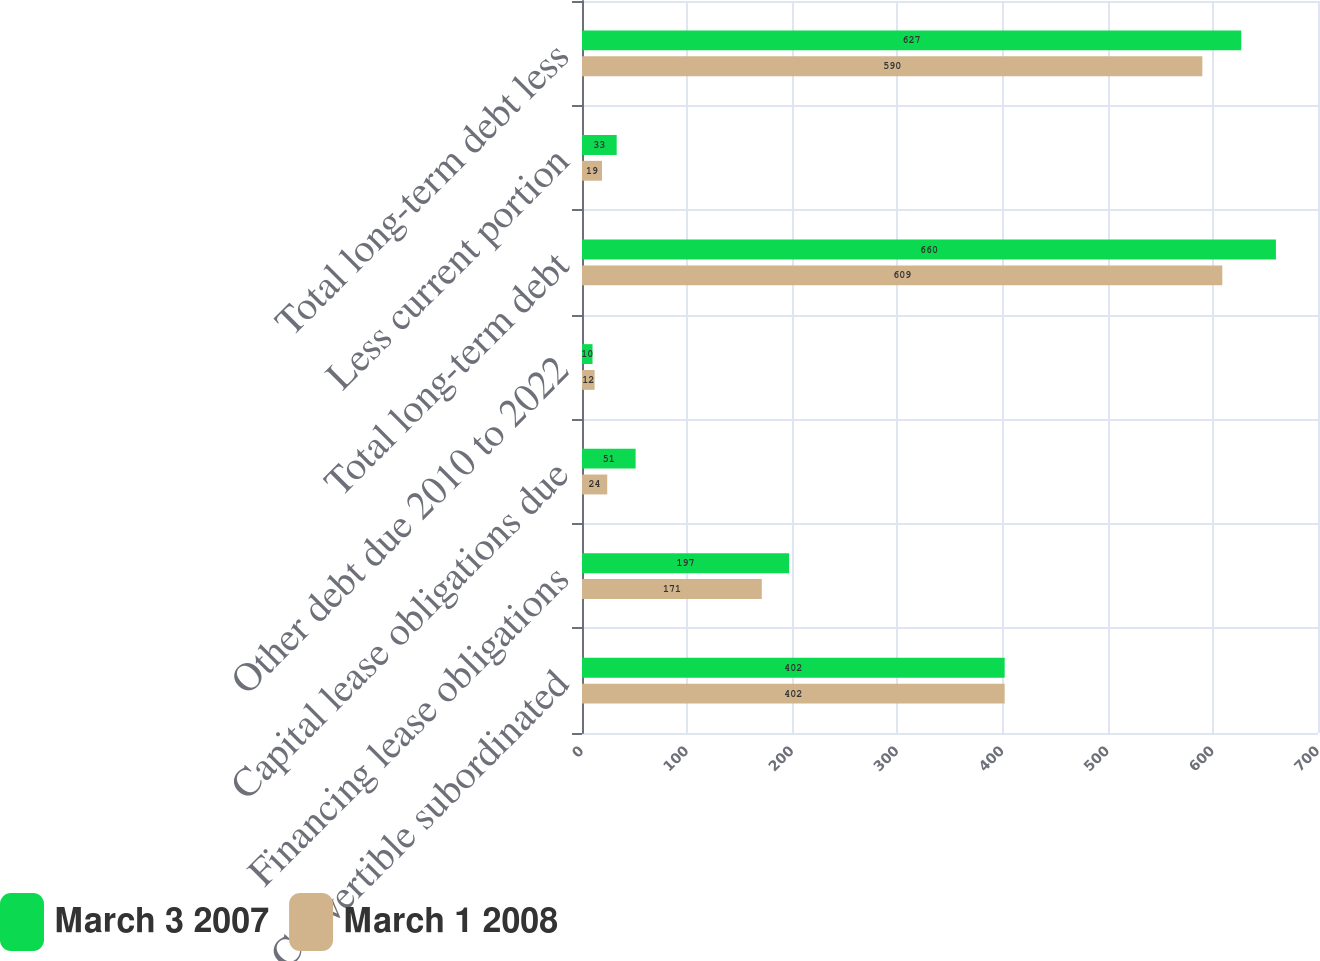Convert chart. <chart><loc_0><loc_0><loc_500><loc_500><stacked_bar_chart><ecel><fcel>Convertible subordinated<fcel>Financing lease obligations<fcel>Capital lease obligations due<fcel>Other debt due 2010 to 2022<fcel>Total long-term debt<fcel>Less current portion<fcel>Total long-term debt less<nl><fcel>March 3 2007<fcel>402<fcel>197<fcel>51<fcel>10<fcel>660<fcel>33<fcel>627<nl><fcel>March 1 2008<fcel>402<fcel>171<fcel>24<fcel>12<fcel>609<fcel>19<fcel>590<nl></chart> 